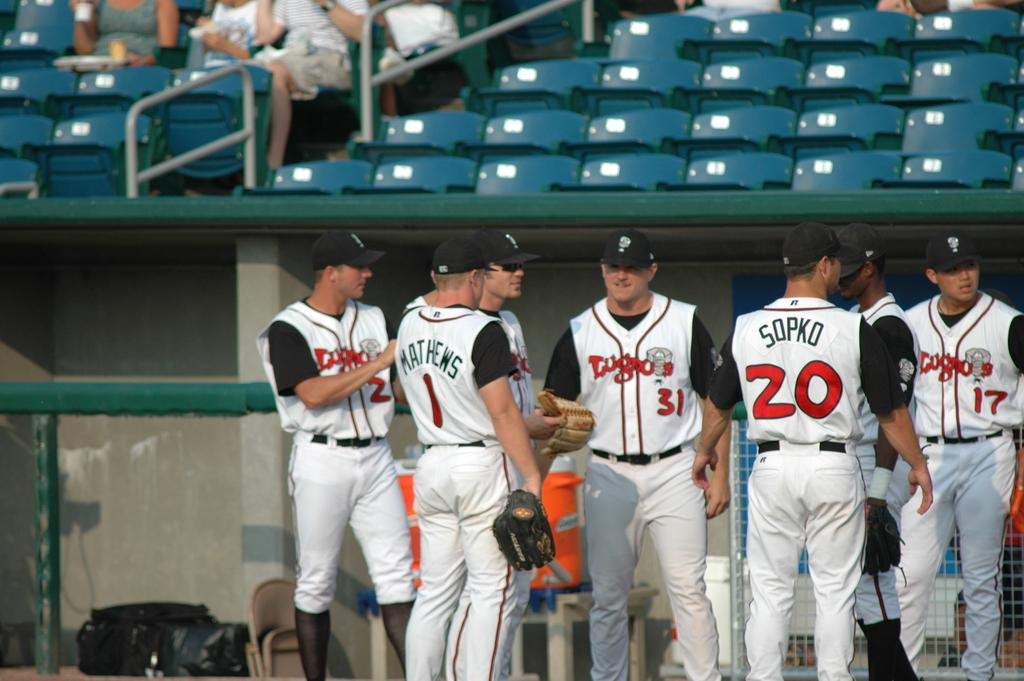<image>
Write a terse but informative summary of the picture. A group of players including Marthews and Sopko. 